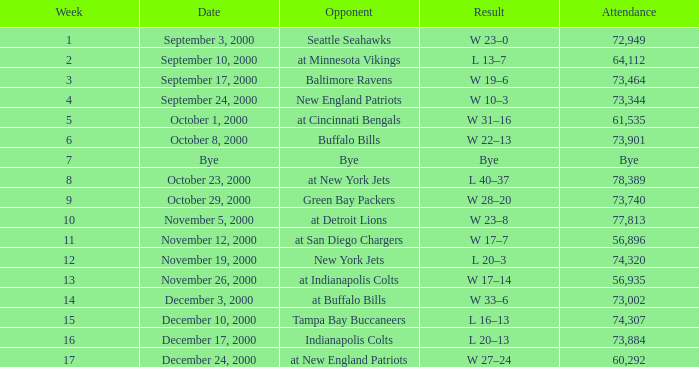What is the Result of the game against the Indianapolis Colts? L 20–13. 